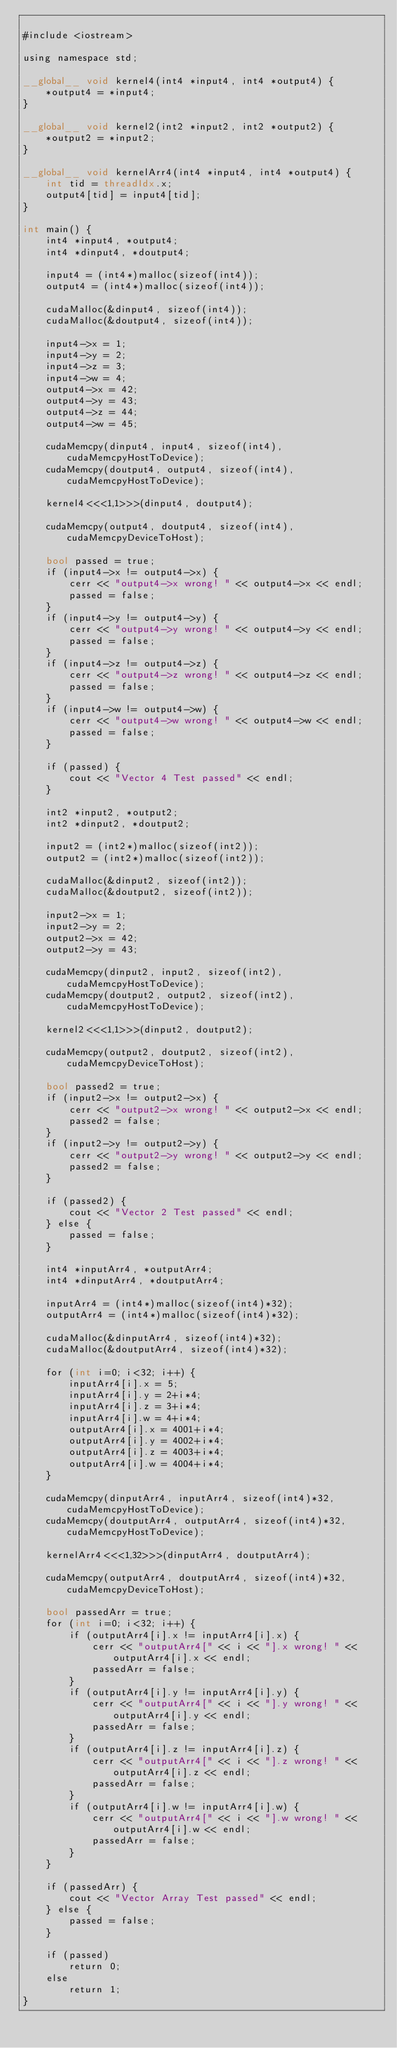<code> <loc_0><loc_0><loc_500><loc_500><_Cuda_>
#include <iostream>

using namespace std;

__global__ void kernel4(int4 *input4, int4 *output4) {
	*output4 = *input4;
}

__global__ void kernel2(int2 *input2, int2 *output2) {
	*output2 = *input2;
}

__global__ void kernelArr4(int4 *input4, int4 *output4) {
	int tid = threadIdx.x;
	output4[tid] = input4[tid];
}

int main() {
	int4 *input4, *output4;
	int4 *dinput4, *doutput4;

	input4 = (int4*)malloc(sizeof(int4));
	output4 = (int4*)malloc(sizeof(int4));

	cudaMalloc(&dinput4, sizeof(int4));
	cudaMalloc(&doutput4, sizeof(int4));

	input4->x = 1;
	input4->y = 2;
	input4->z = 3;
	input4->w = 4;
	output4->x = 42;
	output4->y = 43;
	output4->z = 44;
	output4->w = 45;

	cudaMemcpy(dinput4, input4, sizeof(int4), cudaMemcpyHostToDevice);
	cudaMemcpy(doutput4, output4, sizeof(int4), cudaMemcpyHostToDevice);

	kernel4<<<1,1>>>(dinput4, doutput4);

	cudaMemcpy(output4, doutput4, sizeof(int4), cudaMemcpyDeviceToHost);

	bool passed = true;
	if (input4->x != output4->x) {
		cerr << "output4->x wrong! " << output4->x << endl;
		passed = false;
	}
	if (input4->y != output4->y) {
		cerr << "output4->y wrong! " << output4->y << endl;
		passed = false;
	}
	if (input4->z != output4->z) {
		cerr << "output4->z wrong! " << output4->z << endl;
		passed = false;
	}
	if (input4->w != output4->w) {
		cerr << "output4->w wrong! " << output4->w << endl;
		passed = false;
	}

	if (passed) {
		cout << "Vector 4 Test passed" << endl;
	}

	int2 *input2, *output2;
	int2 *dinput2, *doutput2;

	input2 = (int2*)malloc(sizeof(int2));
	output2 = (int2*)malloc(sizeof(int2));

	cudaMalloc(&dinput2, sizeof(int2));
	cudaMalloc(&doutput2, sizeof(int2));

	input2->x = 1;
	input2->y = 2;
	output2->x = 42;
	output2->y = 43;

	cudaMemcpy(dinput2, input2, sizeof(int2), cudaMemcpyHostToDevice);
	cudaMemcpy(doutput2, output2, sizeof(int2), cudaMemcpyHostToDevice);

	kernel2<<<1,1>>>(dinput2, doutput2);

	cudaMemcpy(output2, doutput2, sizeof(int2), cudaMemcpyDeviceToHost);

	bool passed2 = true;
	if (input2->x != output2->x) {
		cerr << "output2->x wrong! " << output2->x << endl;
		passed2 = false;
	}
	if (input2->y != output2->y) {
		cerr << "output2->y wrong! " << output2->y << endl;
		passed2 = false;
	}

	if (passed2) {
		cout << "Vector 2 Test passed" << endl;
	} else {
		passed = false;
	}

	int4 *inputArr4, *outputArr4;
	int4 *dinputArr4, *doutputArr4;

	inputArr4 = (int4*)malloc(sizeof(int4)*32);
	outputArr4 = (int4*)malloc(sizeof(int4)*32);

	cudaMalloc(&dinputArr4, sizeof(int4)*32);
	cudaMalloc(&doutputArr4, sizeof(int4)*32);

	for (int i=0; i<32; i++) {
		inputArr4[i].x = 5;
		inputArr4[i].y = 2+i*4;
		inputArr4[i].z = 3+i*4;
		inputArr4[i].w = 4+i*4;
		outputArr4[i].x = 4001+i*4;
		outputArr4[i].y = 4002+i*4;
		outputArr4[i].z = 4003+i*4;
		outputArr4[i].w = 4004+i*4;
	}

	cudaMemcpy(dinputArr4, inputArr4, sizeof(int4)*32, cudaMemcpyHostToDevice);
	cudaMemcpy(doutputArr4, outputArr4, sizeof(int4)*32, cudaMemcpyHostToDevice);

	kernelArr4<<<1,32>>>(dinputArr4, doutputArr4);

	cudaMemcpy(outputArr4, doutputArr4, sizeof(int4)*32, cudaMemcpyDeviceToHost);

	bool passedArr = true;
	for (int i=0; i<32; i++) {
		if (outputArr4[i].x != inputArr4[i].x) {
			cerr << "outputArr4[" << i << "].x wrong! " << outputArr4[i].x << endl;
			passedArr = false;
		}
		if (outputArr4[i].y != inputArr4[i].y) {
			cerr << "outputArr4[" << i << "].y wrong! " << outputArr4[i].y << endl;
			passedArr = false;
		}
		if (outputArr4[i].z != inputArr4[i].z) {
			cerr << "outputArr4[" << i << "].z wrong! " << outputArr4[i].z << endl;
			passedArr = false;
		}
		if (outputArr4[i].w != inputArr4[i].w) {
			cerr << "outputArr4[" << i << "].w wrong! " << outputArr4[i].w << endl;
			passedArr = false;
		}
	}

	if (passedArr) {
		cout << "Vector Array Test passed" << endl;
	} else {
		passed = false;
	}

	if (passed)
		return 0;
	else
		return 1;
}</code> 